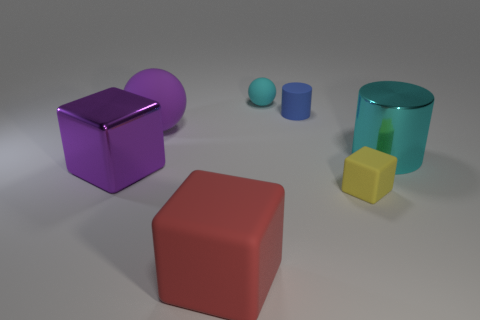Subtract all large cubes. How many cubes are left? 1 Add 3 large purple rubber objects. How many objects exist? 10 Subtract all cylinders. How many objects are left? 5 Add 2 red objects. How many red objects exist? 3 Subtract 0 green balls. How many objects are left? 7 Subtract all brown balls. Subtract all cyan cylinders. How many balls are left? 2 Subtract all metallic cylinders. Subtract all large purple objects. How many objects are left? 4 Add 2 small cyan rubber balls. How many small cyan rubber balls are left? 3 